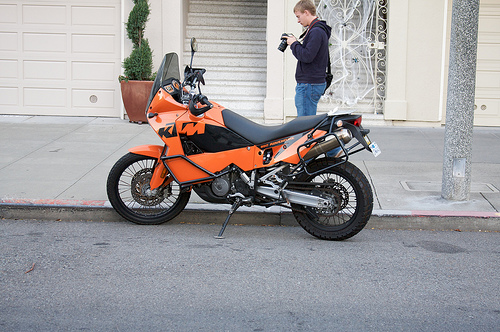<image>
Is there a bike behind the man? No. The bike is not behind the man. From this viewpoint, the bike appears to be positioned elsewhere in the scene. Where is the motorcycle in relation to the sidewalk? Is it in front of the sidewalk? Yes. The motorcycle is positioned in front of the sidewalk, appearing closer to the camera viewpoint. Is there a bike to the right of the man? No. The bike is not to the right of the man. The horizontal positioning shows a different relationship. 